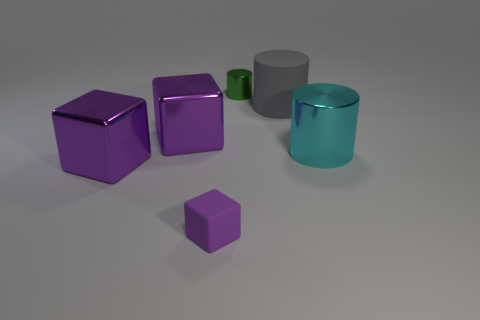The shiny cylinder on the left side of the metallic cylinder that is in front of the tiny shiny cylinder is what color?
Keep it short and to the point. Green. Do the small green object and the tiny cube in front of the tiny shiny cylinder have the same material?
Your answer should be very brief. No. There is a big matte object behind the big cylinder in front of the matte thing that is behind the small purple matte object; what color is it?
Offer a terse response. Gray. Is there anything else that has the same shape as the small green metallic thing?
Offer a very short reply. Yes. Is the number of large gray rubber cubes greater than the number of cylinders?
Provide a short and direct response. No. What number of metallic objects are both to the right of the green cylinder and to the left of the big shiny cylinder?
Offer a very short reply. 0. There is a large purple cube behind the large cyan object; what number of metallic blocks are to the right of it?
Provide a succinct answer. 0. There is a metal cylinder that is on the right side of the small green cylinder; is its size the same as the purple metal thing that is behind the cyan metallic cylinder?
Provide a succinct answer. Yes. How many big purple things are there?
Offer a very short reply. 2. How many tiny purple blocks have the same material as the cyan cylinder?
Your response must be concise. 0. 